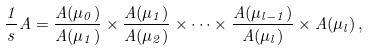<formula> <loc_0><loc_0><loc_500><loc_500>\frac { 1 } { s } A = \frac { A ( \mu _ { 0 } ) } { A ( \mu _ { 1 } ) } \times \frac { A ( \mu _ { 1 } ) } { A ( \mu _ { 2 } ) } \times \dots \times \frac { A ( \mu _ { l - 1 } ) } { A ( \mu _ { l } ) } \times A ( \mu _ { l } ) \, ,</formula> 